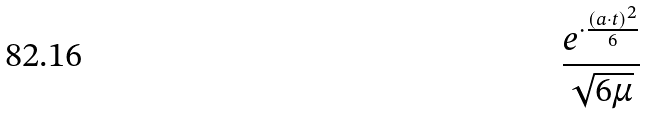Convert formula to latex. <formula><loc_0><loc_0><loc_500><loc_500>\frac { e ^ { \cdot \frac { ( a \cdot t ) ^ { 2 } } { 6 } } } { \sqrt { 6 \mu } }</formula> 